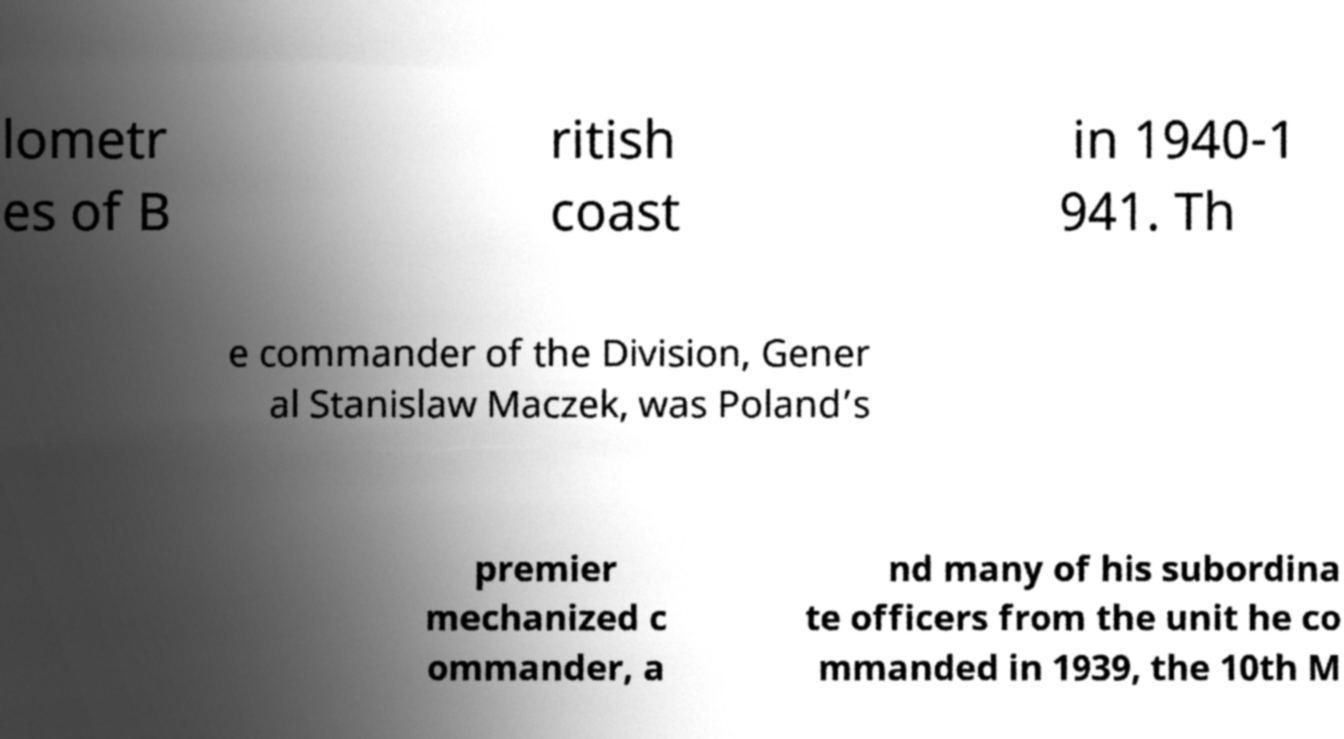Can you read and provide the text displayed in the image?This photo seems to have some interesting text. Can you extract and type it out for me? lometr es of B ritish coast in 1940-1 941. Th e commander of the Division, Gener al Stanislaw Maczek, was Poland’s premier mechanized c ommander, a nd many of his subordina te officers from the unit he co mmanded in 1939, the 10th M 